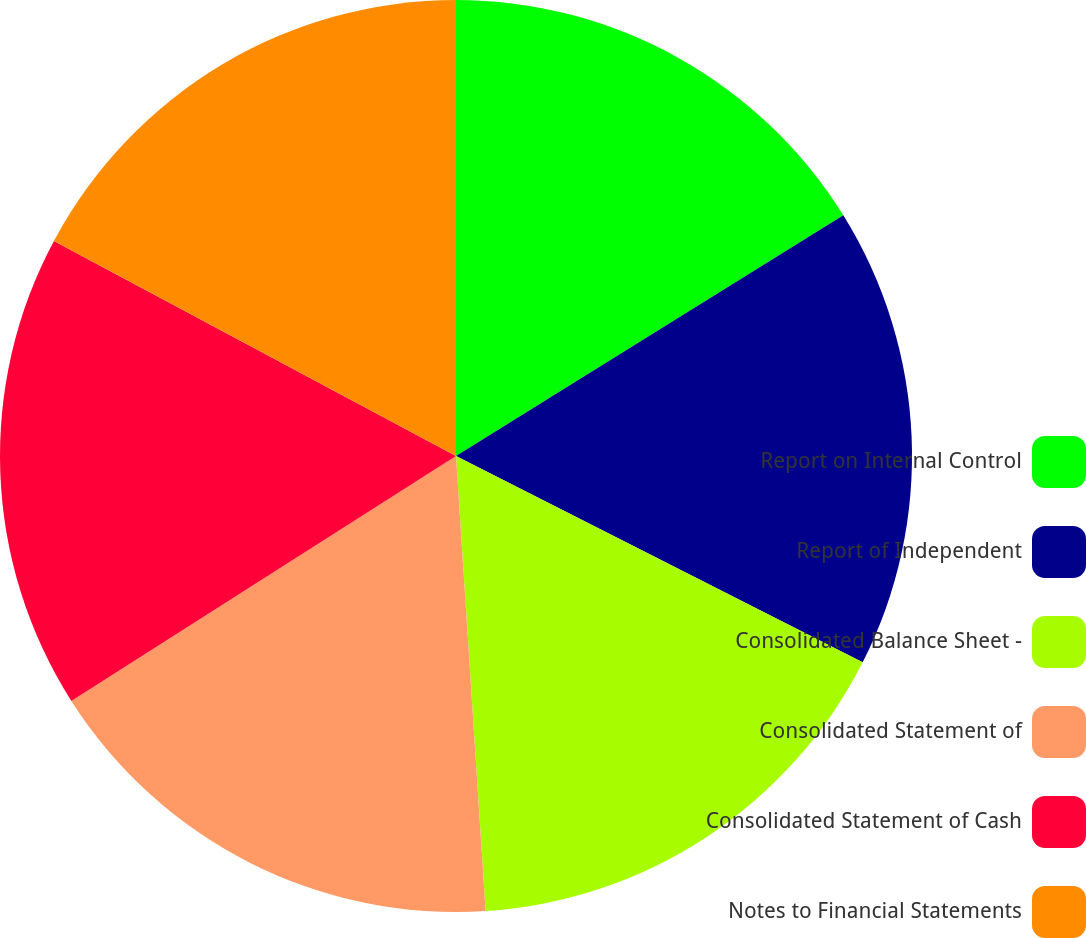<chart> <loc_0><loc_0><loc_500><loc_500><pie_chart><fcel>Report on Internal Control<fcel>Report of Independent<fcel>Consolidated Balance Sheet -<fcel>Consolidated Statement of<fcel>Consolidated Statement of Cash<fcel>Notes to Financial Statements<nl><fcel>16.15%<fcel>16.32%<fcel>16.49%<fcel>17.01%<fcel>16.84%<fcel>17.18%<nl></chart> 